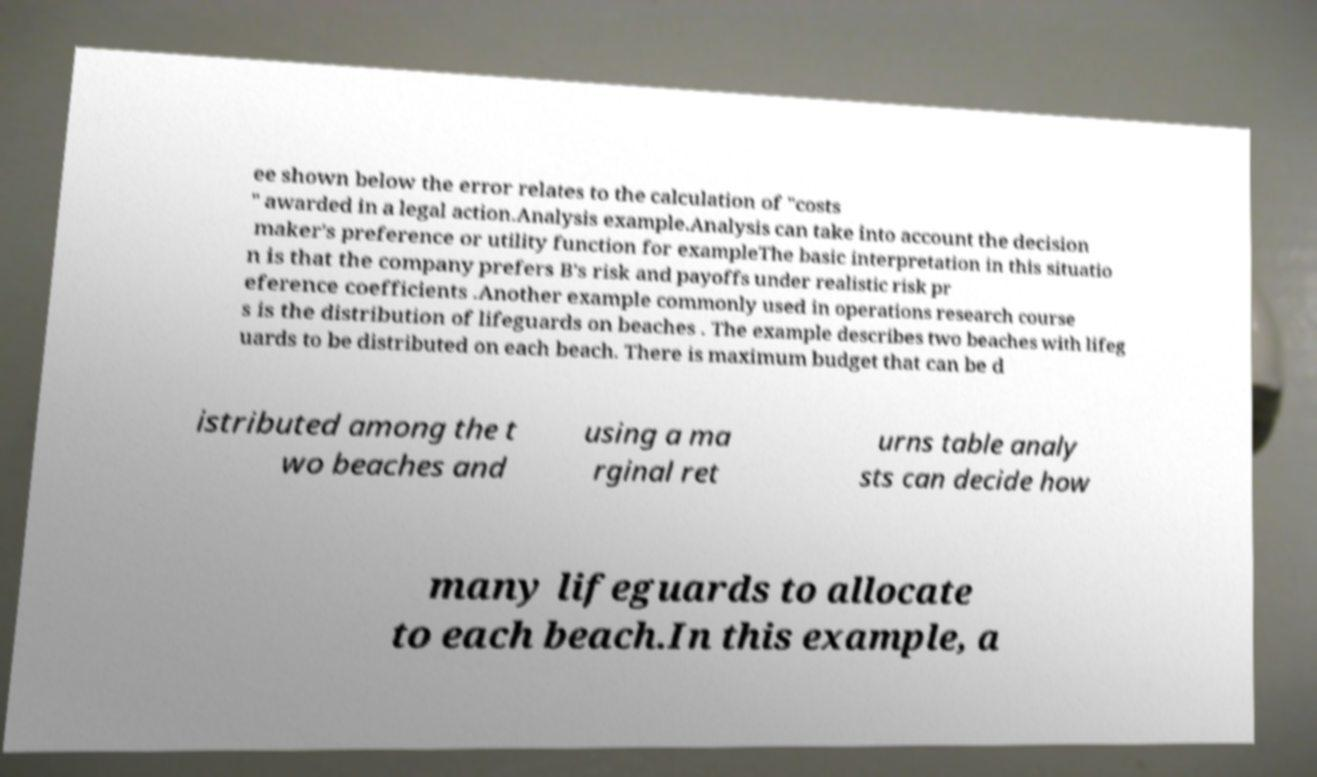There's text embedded in this image that I need extracted. Can you transcribe it verbatim? ee shown below the error relates to the calculation of "costs " awarded in a legal action.Analysis example.Analysis can take into account the decision maker's preference or utility function for exampleThe basic interpretation in this situatio n is that the company prefers B's risk and payoffs under realistic risk pr eference coefficients .Another example commonly used in operations research course s is the distribution of lifeguards on beaches . The example describes two beaches with lifeg uards to be distributed on each beach. There is maximum budget that can be d istributed among the t wo beaches and using a ma rginal ret urns table analy sts can decide how many lifeguards to allocate to each beach.In this example, a 